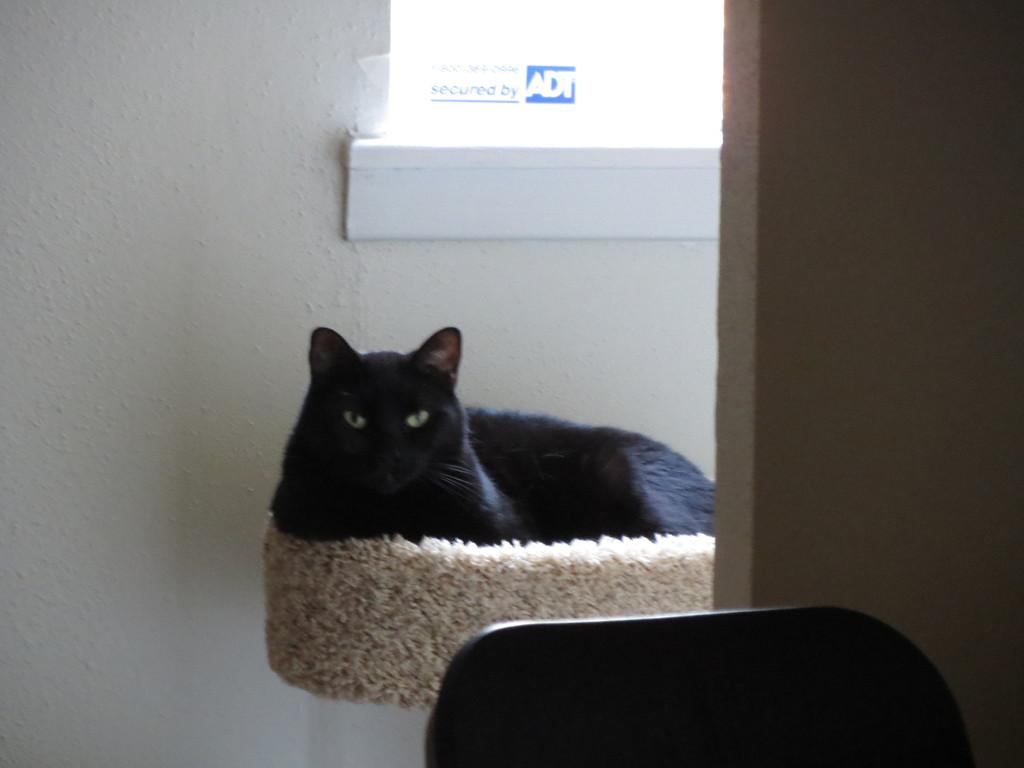What type of animal is in the image? There is a cat in the image. What type of structure is visible in the image? There are walls visible in the image. What type of furniture is at the bottom of the image? There appears to be a chair at the bottom of the image. What type of wave can be seen crashing on the shore in the image? There is no wave or shore present in the image; it features a cat, walls, and a chair. 